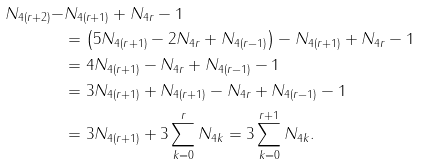Convert formula to latex. <formula><loc_0><loc_0><loc_500><loc_500>N _ { 4 ( r + 2 ) } - & N _ { 4 ( r + 1 ) } + N _ { 4 r } - 1 \\ & = \left ( 5 N _ { 4 ( r + 1 ) } - 2 N _ { 4 r } + N _ { 4 ( r - 1 ) } \right ) - N _ { 4 ( r + 1 ) } + N _ { 4 r } - 1 \\ & = 4 N _ { 4 ( r + 1 ) } - N _ { 4 r } + N _ { 4 ( r - 1 ) } - 1 \\ & = 3 N _ { 4 ( r + 1 ) } + N _ { 4 ( r + 1 ) } - N _ { 4 r } + N _ { 4 ( r - 1 ) } - 1 \\ & = 3 N _ { 4 ( r + 1 ) } + 3 \sum _ { k = 0 } ^ { r } N _ { 4 k } = 3 \sum _ { k = 0 } ^ { r + 1 } N _ { 4 k } .</formula> 